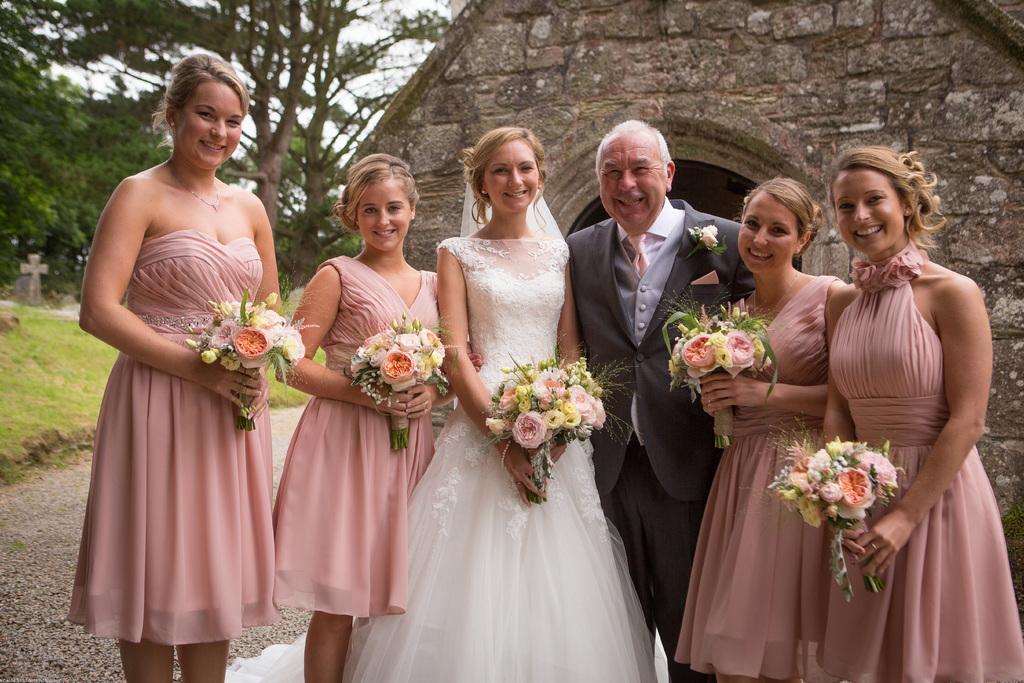Describe this image in one or two sentences. In this image we can see a few people, some of them are holding flower bouquets, there are trees, a cross symbol, and a house, also we can see the sky. 